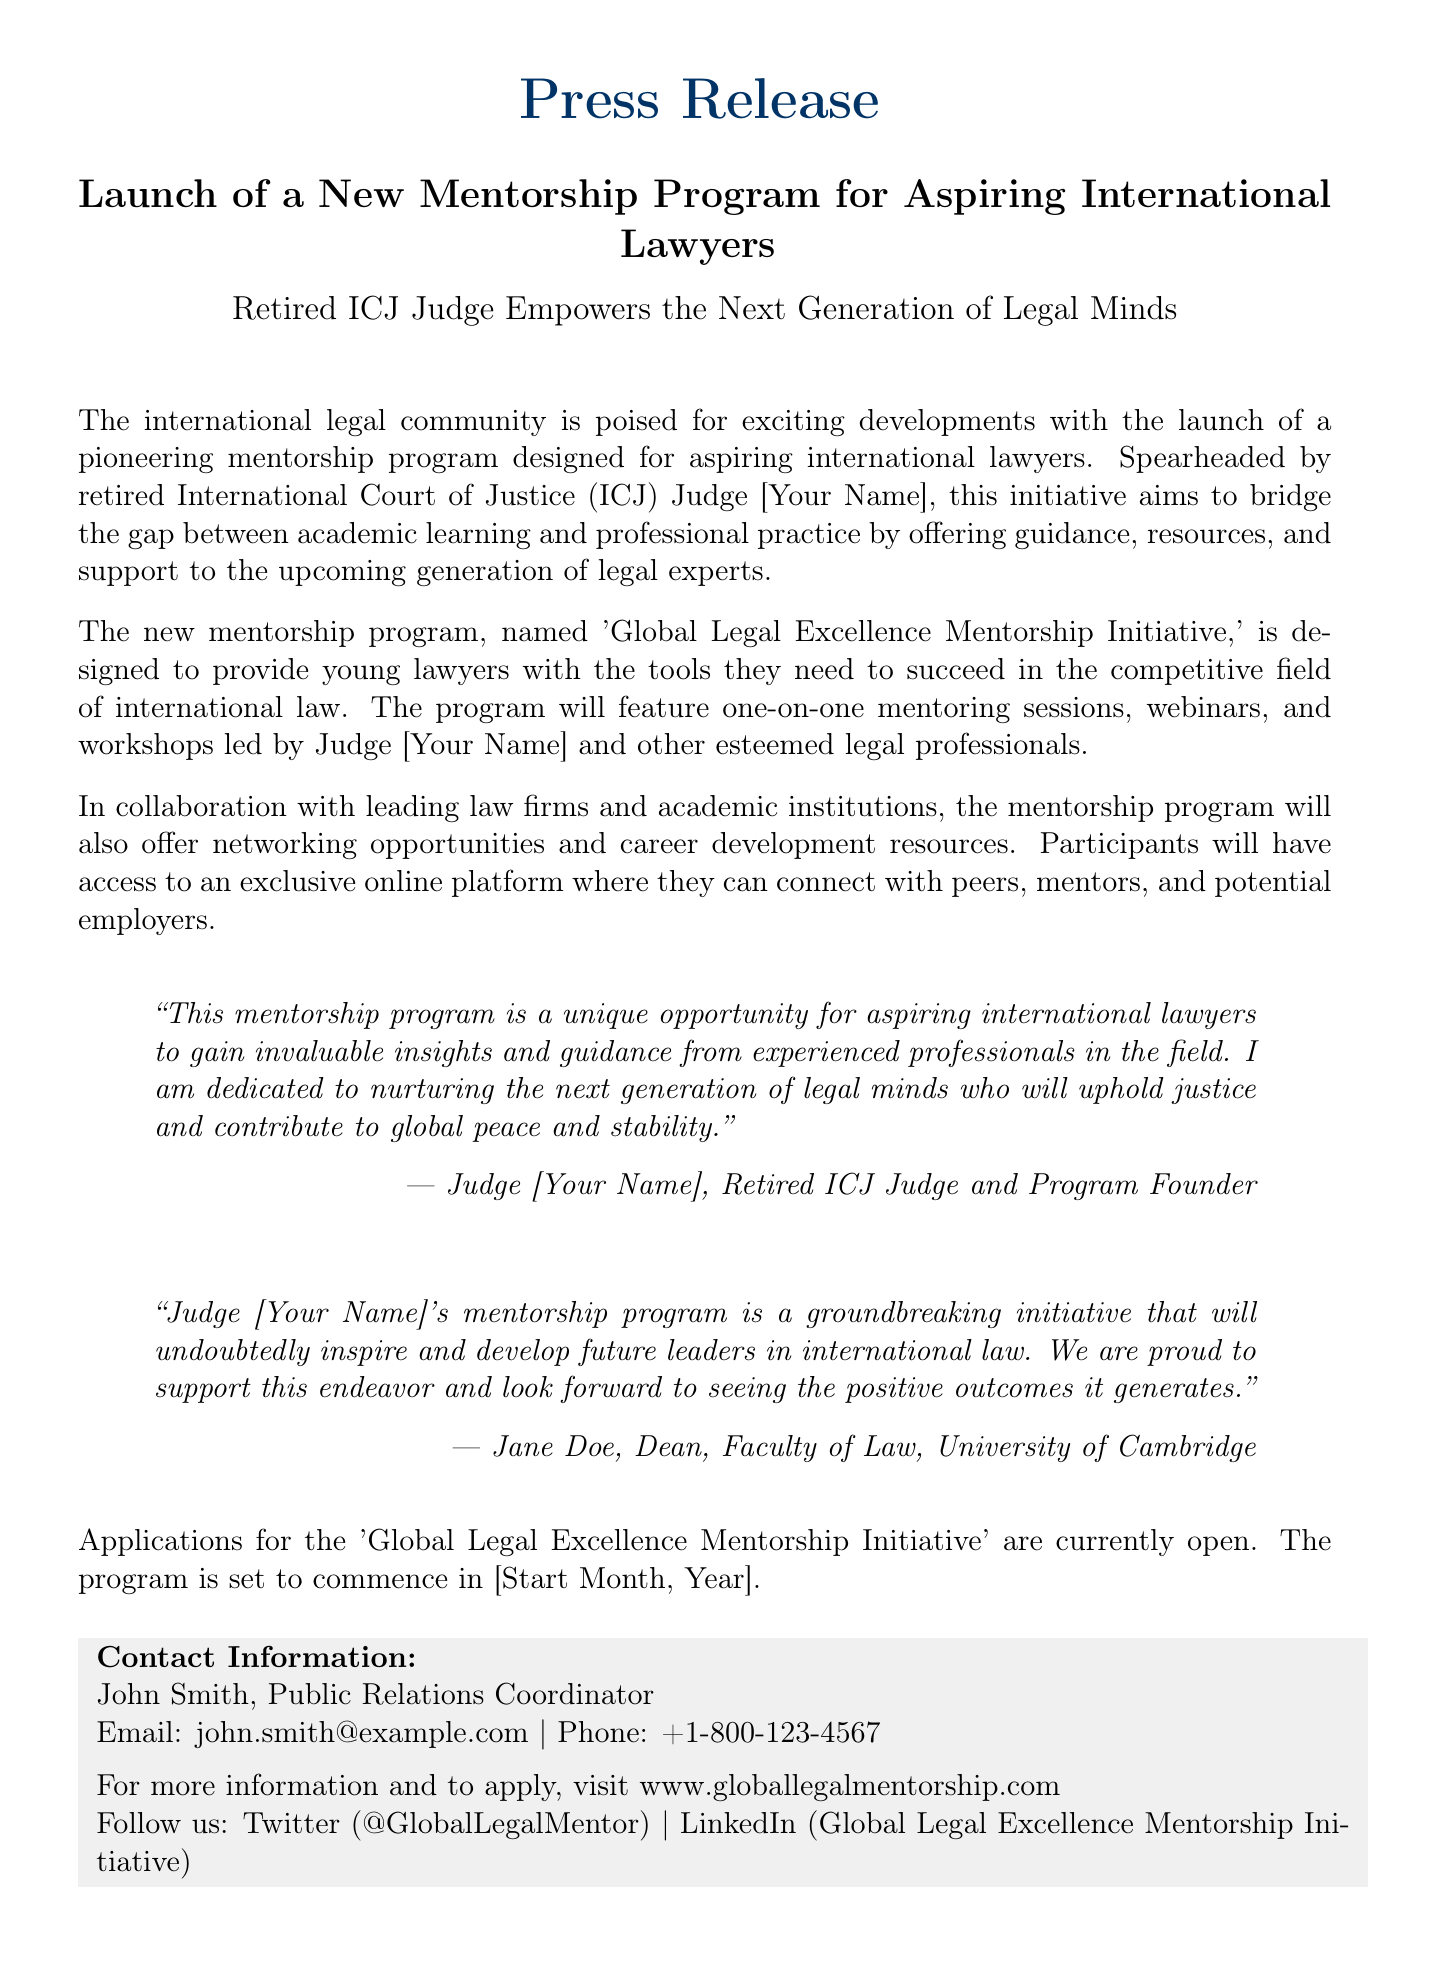What is the name of the mentorship program? The name of the program is explicitly mentioned in the document as 'Global Legal Excellence Mentorship Initiative.'
Answer: Global Legal Excellence Mentorship Initiative Who is the founder of the mentorship program? The document states that the program is spearheaded by a retired ICJ Judge, referred to as Judge [Your Name].
Answer: Judge [Your Name] When is the program set to commence? The commencement of the program is indicated in the document as occurring in [Start Month, Year].
Answer: [Start Month, Year] What kind of sessions will the program include? The document outlines that the program will feature one-on-one mentoring sessions, webinars, and workshops.
Answer: One-on-one mentoring sessions, webinars, and workshops Who expressed support for the mentorship initiative in the document? The Dean of the Faculty of Law at the University of Cambridge, Jane Doe, is quoted in the document expressing support.
Answer: Jane Doe What is the primary goal of the mentorship program? The document mentions that the program aims to bridge the gap between academic learning and professional practice.
Answer: Bridge the gap between academic learning and professional practice How can participants apply for the program? The document contains a website link for participants to visit for more information and to apply.
Answer: www.globallegalmentorship.com What type of opportunities will participants have access to? The document specifies that participants will have access to networking opportunities and career development resources.
Answer: Networking opportunities and career development resources 